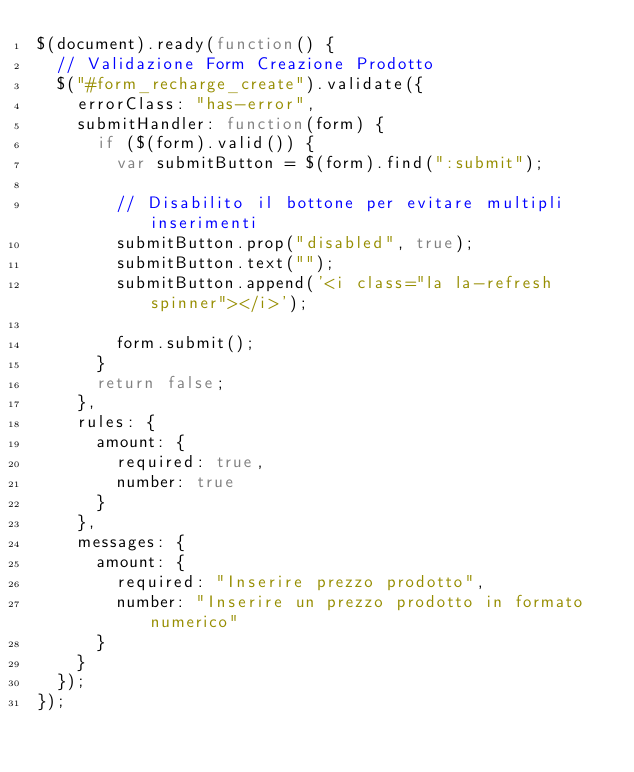<code> <loc_0><loc_0><loc_500><loc_500><_JavaScript_>$(document).ready(function() {
  // Validazione Form Creazione Prodotto
  $("#form_recharge_create").validate({
    errorClass: "has-error",
    submitHandler: function(form) {
      if ($(form).valid()) {
        var submitButton = $(form).find(":submit");

        // Disabilito il bottone per evitare multipli inserimenti
        submitButton.prop("disabled", true);
        submitButton.text("");
        submitButton.append('<i class="la la-refresh spinner"></i>');

        form.submit();
      }
      return false;
    },
    rules: {
      amount: {
        required: true,
        number: true
      }
    },
    messages: {
      amount: {
        required: "Inserire prezzo prodotto",
        number: "Inserire un prezzo prodotto in formato numerico"
      }
    }
  });
});
</code> 